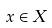<formula> <loc_0><loc_0><loc_500><loc_500>x \in X</formula> 